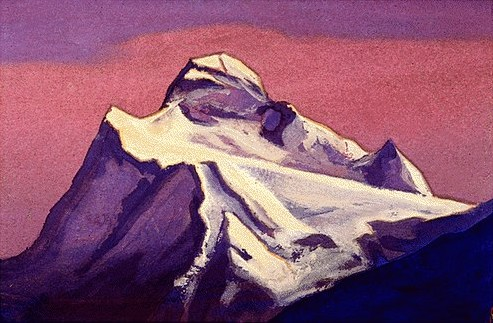Could this work be inspired by any particular artist or art movement besides Impressionism? While primarily impressionistic, elements of the painting, such as the emotional use of color and the choice of rugged natural scenery, may also draw inspiration from the Romanticism movement. This movement emphasized intense emotions and glorified nature, often using dramatic and wild landscapes to explore themes of beauty and power. The expressive use of color to convey mood could also hint at influences from the later Expressionist movement, which prioritized emotional experience over realism. 